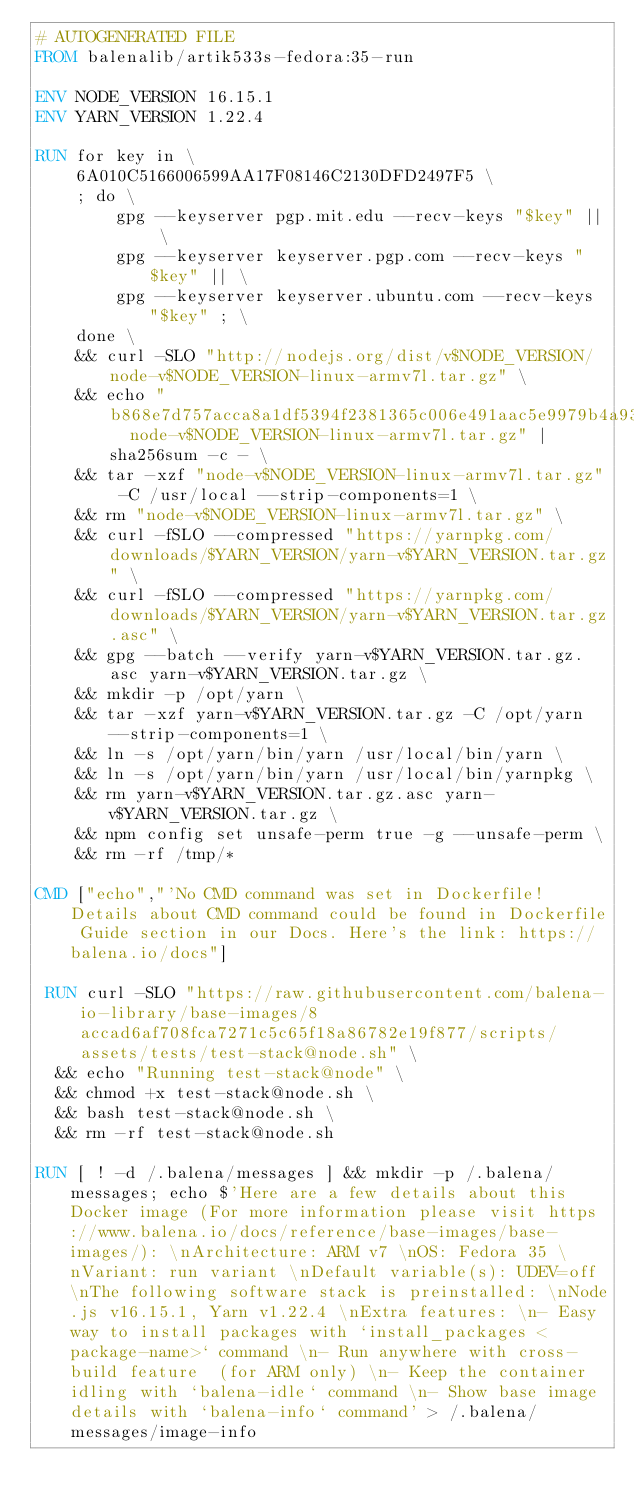<code> <loc_0><loc_0><loc_500><loc_500><_Dockerfile_># AUTOGENERATED FILE
FROM balenalib/artik533s-fedora:35-run

ENV NODE_VERSION 16.15.1
ENV YARN_VERSION 1.22.4

RUN for key in \
	6A010C5166006599AA17F08146C2130DFD2497F5 \
	; do \
		gpg --keyserver pgp.mit.edu --recv-keys "$key" || \
		gpg --keyserver keyserver.pgp.com --recv-keys "$key" || \
		gpg --keyserver keyserver.ubuntu.com --recv-keys "$key" ; \
	done \
	&& curl -SLO "http://nodejs.org/dist/v$NODE_VERSION/node-v$NODE_VERSION-linux-armv7l.tar.gz" \
	&& echo "b868e7d757acca8a1df5394f2381365c006e491aac5e9979b4a933ca66698f8c  node-v$NODE_VERSION-linux-armv7l.tar.gz" | sha256sum -c - \
	&& tar -xzf "node-v$NODE_VERSION-linux-armv7l.tar.gz" -C /usr/local --strip-components=1 \
	&& rm "node-v$NODE_VERSION-linux-armv7l.tar.gz" \
	&& curl -fSLO --compressed "https://yarnpkg.com/downloads/$YARN_VERSION/yarn-v$YARN_VERSION.tar.gz" \
	&& curl -fSLO --compressed "https://yarnpkg.com/downloads/$YARN_VERSION/yarn-v$YARN_VERSION.tar.gz.asc" \
	&& gpg --batch --verify yarn-v$YARN_VERSION.tar.gz.asc yarn-v$YARN_VERSION.tar.gz \
	&& mkdir -p /opt/yarn \
	&& tar -xzf yarn-v$YARN_VERSION.tar.gz -C /opt/yarn --strip-components=1 \
	&& ln -s /opt/yarn/bin/yarn /usr/local/bin/yarn \
	&& ln -s /opt/yarn/bin/yarn /usr/local/bin/yarnpkg \
	&& rm yarn-v$YARN_VERSION.tar.gz.asc yarn-v$YARN_VERSION.tar.gz \
	&& npm config set unsafe-perm true -g --unsafe-perm \
	&& rm -rf /tmp/*

CMD ["echo","'No CMD command was set in Dockerfile! Details about CMD command could be found in Dockerfile Guide section in our Docs. Here's the link: https://balena.io/docs"]

 RUN curl -SLO "https://raw.githubusercontent.com/balena-io-library/base-images/8accad6af708fca7271c5c65f18a86782e19f877/scripts/assets/tests/test-stack@node.sh" \
  && echo "Running test-stack@node" \
  && chmod +x test-stack@node.sh \
  && bash test-stack@node.sh \
  && rm -rf test-stack@node.sh 

RUN [ ! -d /.balena/messages ] && mkdir -p /.balena/messages; echo $'Here are a few details about this Docker image (For more information please visit https://www.balena.io/docs/reference/base-images/base-images/): \nArchitecture: ARM v7 \nOS: Fedora 35 \nVariant: run variant \nDefault variable(s): UDEV=off \nThe following software stack is preinstalled: \nNode.js v16.15.1, Yarn v1.22.4 \nExtra features: \n- Easy way to install packages with `install_packages <package-name>` command \n- Run anywhere with cross-build feature  (for ARM only) \n- Keep the container idling with `balena-idle` command \n- Show base image details with `balena-info` command' > /.balena/messages/image-info</code> 